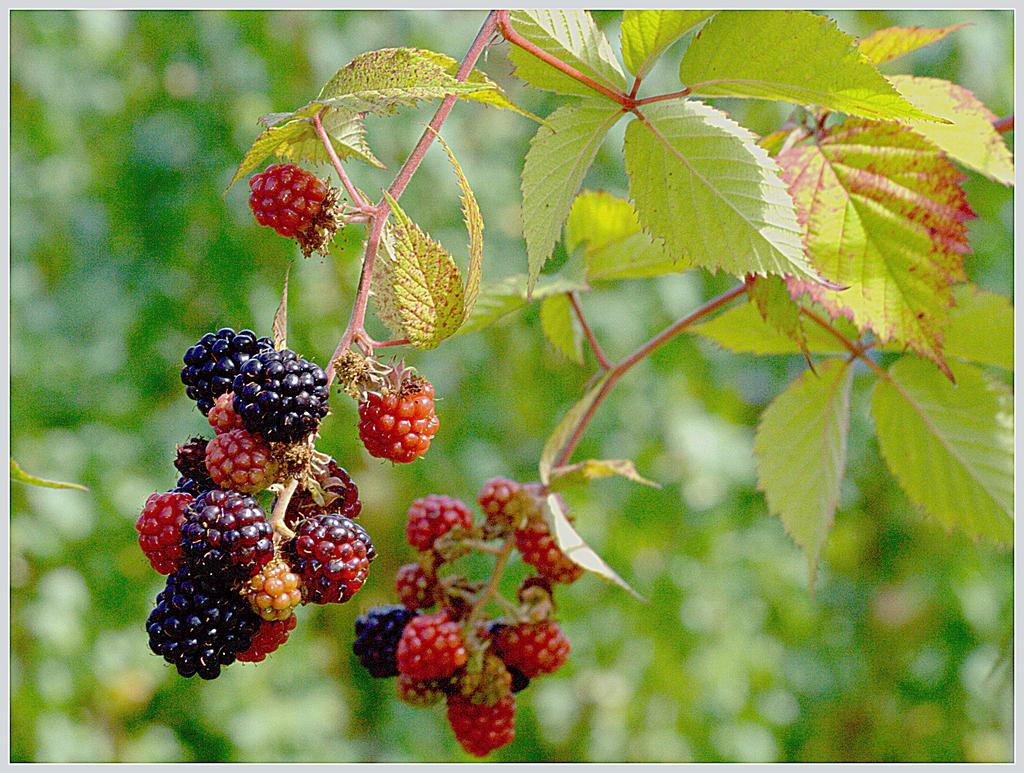What is hanging in the foreground of the image? There are berries hanging in the foreground of the image. What can be seen on the right side of the image? There is a plant on the right side of the image. What type of vegetation is visible in the background of the image? There are trees visible in the background of the image. What type of fruit is being discussed by the trees in the image? There is no discussion or fruit present in the image; it features berries, a plant, and trees. Is there any celery visible in the image? There is no celery present in the image. 